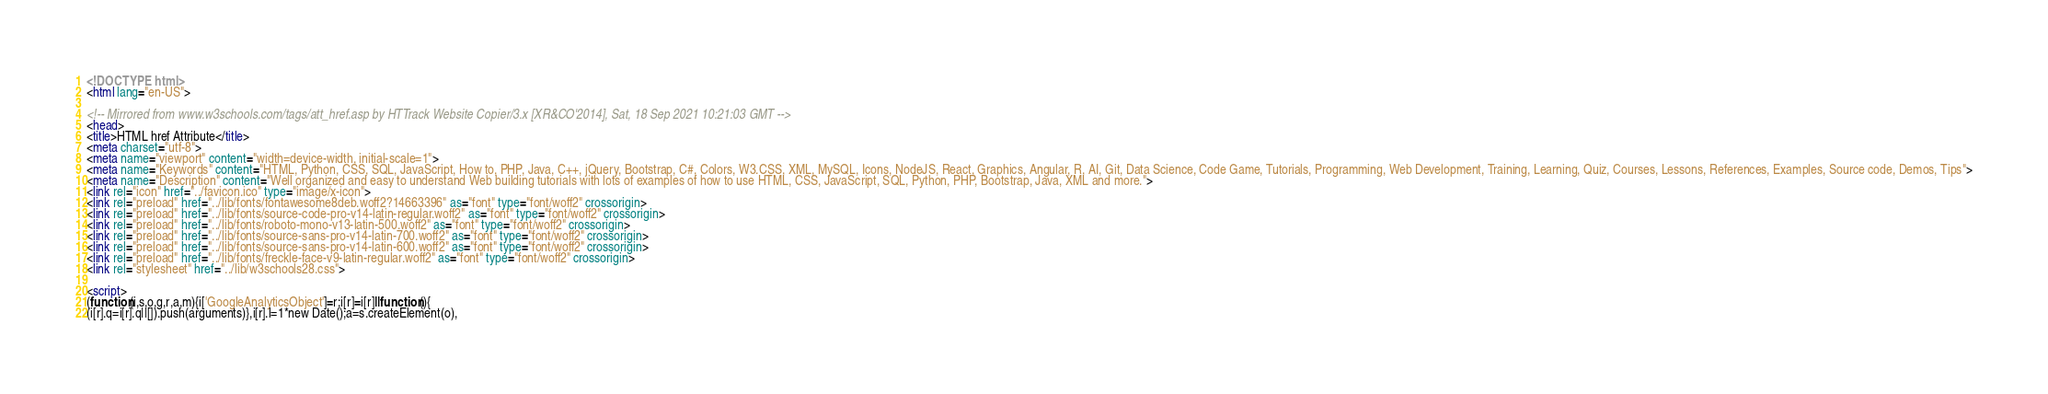Convert code to text. <code><loc_0><loc_0><loc_500><loc_500><_HTML_>
<!DOCTYPE html>
<html lang="en-US">

<!-- Mirrored from www.w3schools.com/tags/att_href.asp by HTTrack Website Copier/3.x [XR&CO'2014], Sat, 18 Sep 2021 10:21:03 GMT -->
<head>
<title>HTML href Attribute</title>
<meta charset="utf-8">
<meta name="viewport" content="width=device-width, initial-scale=1">
<meta name="Keywords" content="HTML, Python, CSS, SQL, JavaScript, How to, PHP, Java, C++, jQuery, Bootstrap, C#, Colors, W3.CSS, XML, MySQL, Icons, NodeJS, React, Graphics, Angular, R, AI, Git, Data Science, Code Game, Tutorials, Programming, Web Development, Training, Learning, Quiz, Courses, Lessons, References, Examples, Source code, Demos, Tips">
<meta name="Description" content="Well organized and easy to understand Web building tutorials with lots of examples of how to use HTML, CSS, JavaScript, SQL, Python, PHP, Bootstrap, Java, XML and more.">
<link rel="icon" href="../favicon.ico" type="image/x-icon">
<link rel="preload" href="../lib/fonts/fontawesome8deb.woff2?14663396" as="font" type="font/woff2" crossorigin> 
<link rel="preload" href="../lib/fonts/source-code-pro-v14-latin-regular.woff2" as="font" type="font/woff2" crossorigin> 
<link rel="preload" href="../lib/fonts/roboto-mono-v13-latin-500.woff2" as="font" type="font/woff2" crossorigin> 
<link rel="preload" href="../lib/fonts/source-sans-pro-v14-latin-700.woff2" as="font" type="font/woff2" crossorigin> 
<link rel="preload" href="../lib/fonts/source-sans-pro-v14-latin-600.woff2" as="font" type="font/woff2" crossorigin> 
<link rel="preload" href="../lib/fonts/freckle-face-v9-latin-regular.woff2" as="font" type="font/woff2" crossorigin> 
<link rel="stylesheet" href="../lib/w3schools28.css">

<script>
(function(i,s,o,g,r,a,m){i['GoogleAnalyticsObject']=r;i[r]=i[r]||function(){
(i[r].q=i[r].q||[]).push(arguments)},i[r].l=1*new Date();a=s.createElement(o),</code> 